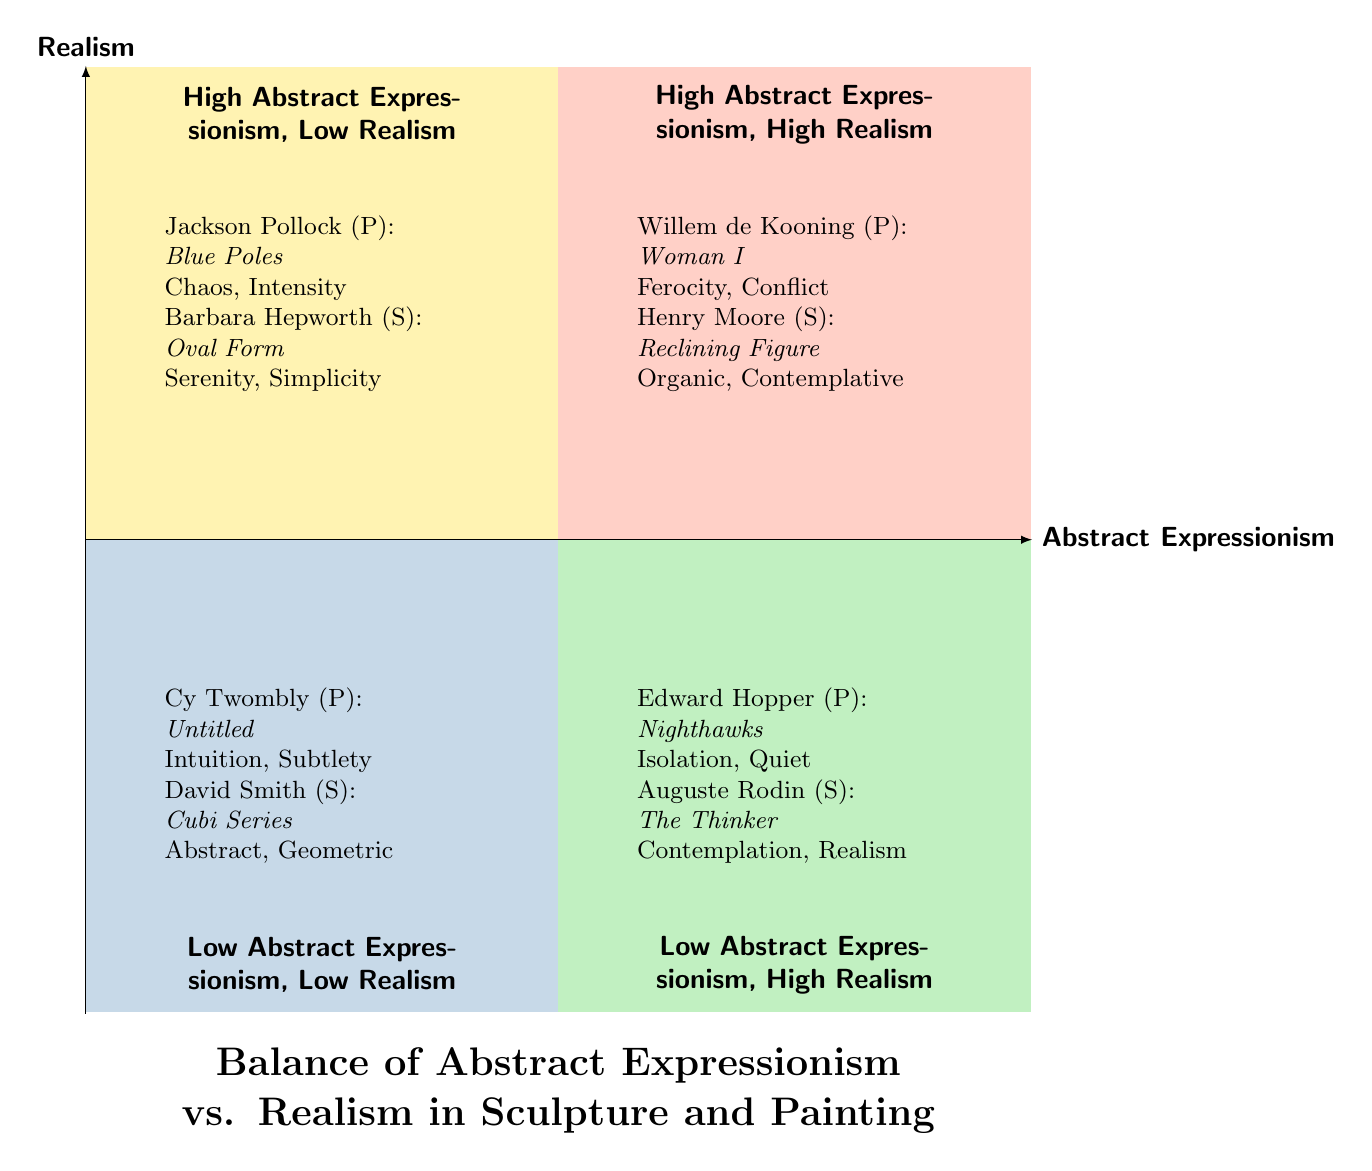What is the title of the diagram? The title is explicitly stated at the bottom of the diagram, which is "Balance of Abstract Expressionism vs. Realism in Sculpture and Painting."
Answer: Balance of Abstract Expressionism vs. Realism in Sculpture and Painting How many quadrants are present in the diagram? The diagram presents four distinct quadrants, as indicated by their labels in the chart.
Answer: 4 Name an artist in the "High Abstract Expressionism, Low Realism" quadrant. This quadrant includes Jackson Pollock, as mentioned under the examples for this section.
Answer: Jackson Pollock Which emotional tone is associated with Edward Hopper's "Nighthawks"? The emotional tones listed for Edward Hopper's "Nighthawks" are "Isolation" and "Quiet," as specified in the quadrant.
Answer: Isolation, Quiet What medium is used by David Smith in the "Low Abstract Expressionism, Low Realism" quadrant? In this quadrant, David Smith is noted as a sculptor, showing that his medium is sculpture.
Answer: Sculpture Explain the relationship between "Willem de Kooning" and "Henry Moore" in the diagram. Both artists are located in the "High Abstract Expressionism, High Realism" quadrant, indicating they create works that combine abstract expressionist techniques with realistic elements.
Answer: High Abstract Expressionism, High Realism What emotional tone is used to describe Barbara Hepworth's "Oval Form"? The emotional tone attributed to Barbara Hepworth's "Oval Form" is "Serenity" and "Simplicity," as noted in the corresponding quadrant.
Answer: Serenity, Simplicity Which quadrant contains works that aim to depict the subject matter accurately? The "Low Abstract Expressionism, High Realism" quadrant focuses on accurate depictions of the subject matter while conveying emotional depth.
Answer: Low Abstract Expressionism, High Realism What is the notable work of Cy Twombly mentioned in the diagram? The notable work of Cy Twombly referenced in the diagram is "Untitled," highlighted in the "Low Abstract Expressionism, Low Realism" quadrant.
Answer: Untitled 